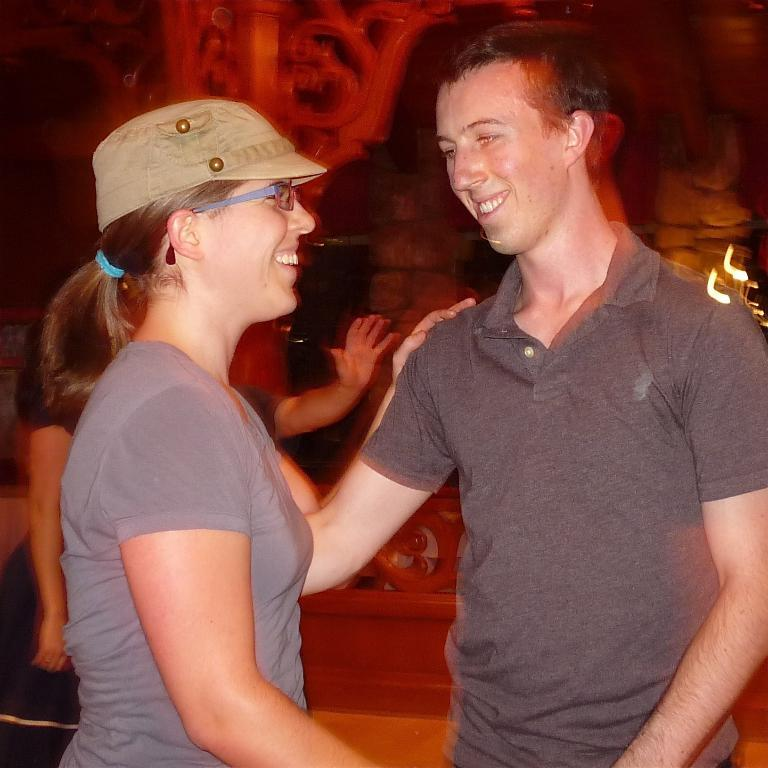How many people are in the image? There are two people in the image. What are the two people doing? The two people are laughing and looking at each other. Can you describe the people in the background? The background of the image is blurred, so it is difficult to see the people in the background clearly. Where is the bomb located in the image? There is no bomb present in the image. What type of bubble can be seen floating in the background? There is no bubble present in the image. 